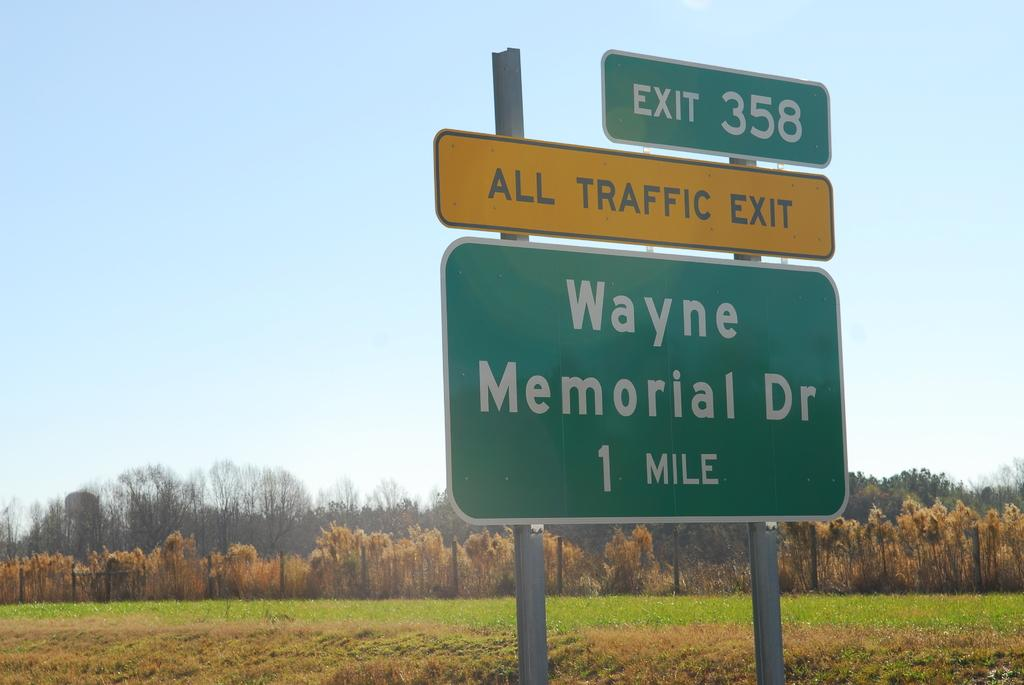<image>
Describe the image concisely. A yellow road sign says all traffic should exit. 